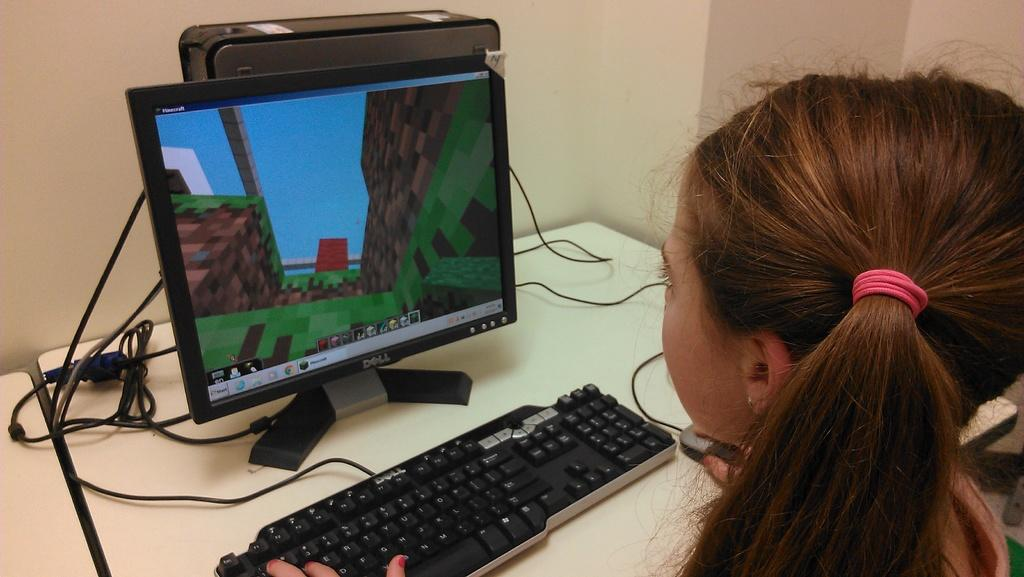<image>
Render a clear and concise summary of the photo. A little girl at a computer playing the game Minecraft. 